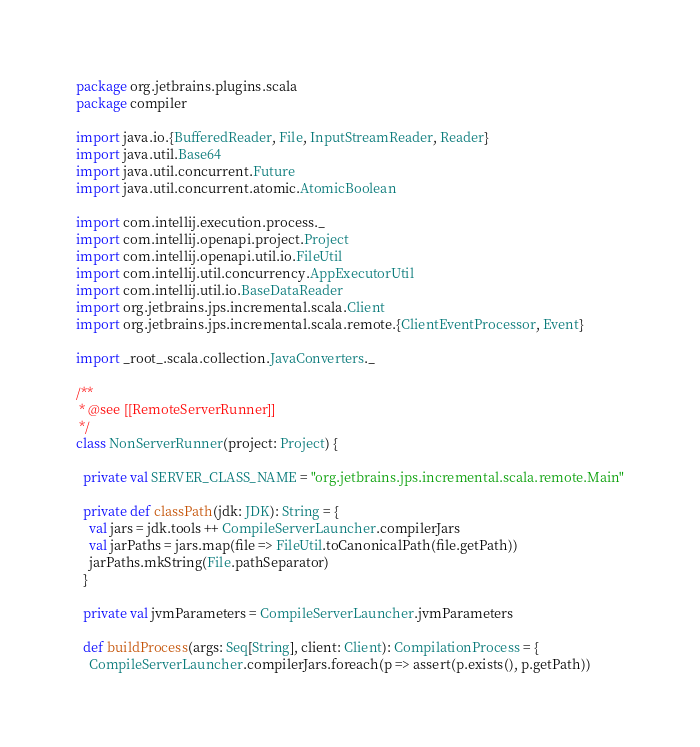Convert code to text. <code><loc_0><loc_0><loc_500><loc_500><_Scala_>package org.jetbrains.plugins.scala
package compiler

import java.io.{BufferedReader, File, InputStreamReader, Reader}
import java.util.Base64
import java.util.concurrent.Future
import java.util.concurrent.atomic.AtomicBoolean

import com.intellij.execution.process._
import com.intellij.openapi.project.Project
import com.intellij.openapi.util.io.FileUtil
import com.intellij.util.concurrency.AppExecutorUtil
import com.intellij.util.io.BaseDataReader
import org.jetbrains.jps.incremental.scala.Client
import org.jetbrains.jps.incremental.scala.remote.{ClientEventProcessor, Event}

import _root_.scala.collection.JavaConverters._

/**
 * @see [[RemoteServerRunner]]
 */
class NonServerRunner(project: Project) {

  private val SERVER_CLASS_NAME = "org.jetbrains.jps.incremental.scala.remote.Main"

  private def classPath(jdk: JDK): String = {
    val jars = jdk.tools ++ CompileServerLauncher.compilerJars
    val jarPaths = jars.map(file => FileUtil.toCanonicalPath(file.getPath))
    jarPaths.mkString(File.pathSeparator)
  }

  private val jvmParameters = CompileServerLauncher.jvmParameters
  
  def buildProcess(args: Seq[String], client: Client): CompilationProcess = {
    CompileServerLauncher.compilerJars.foreach(p => assert(p.exists(), p.getPath))
</code> 